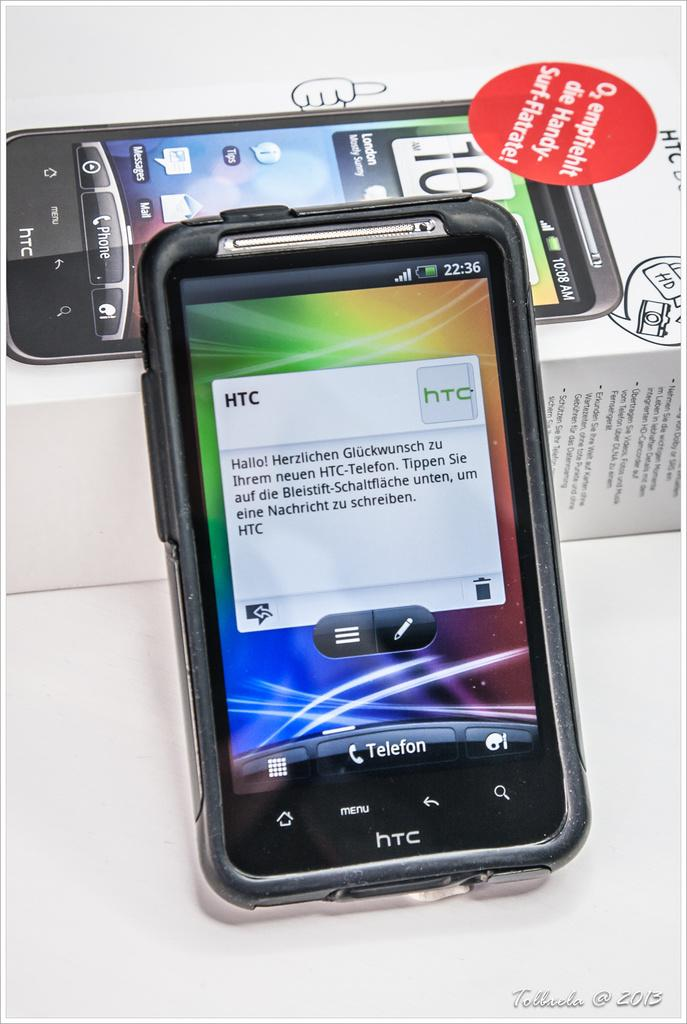<image>
Create a compact narrative representing the image presented. A cell phone with a multi colored background and the letters HTC 